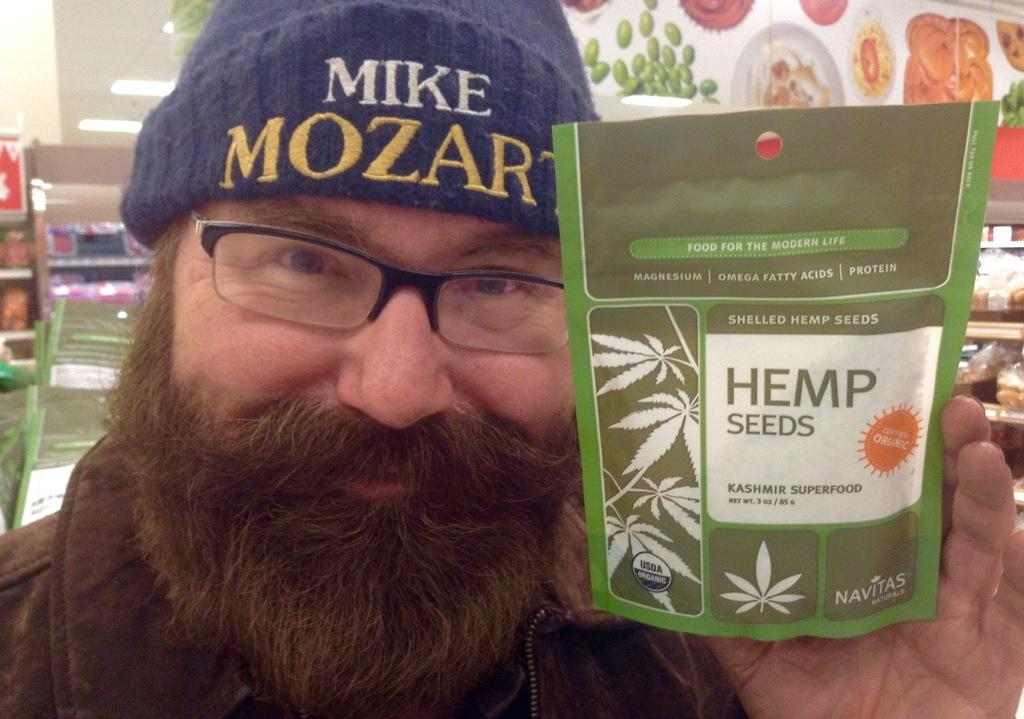Who is present in the image? There is a man in the image. What is the man wearing on his head? The man is wearing a cap. What accessory is the man wearing on his face? The man is wearing glasses. What is the man holding in his hand? The man is holding a packet in his hand. What can be seen in the background of the image? There are food items in the background of the image. What type of twig is the man using to navigate the airport in the image? There is no twig or airport present in the image; it features a man wearing a cap and glasses, holding a packet, and standing in front of food items. 